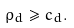Convert formula to latex. <formula><loc_0><loc_0><loc_500><loc_500>\rho _ { d } \geq c _ { d } .</formula> 